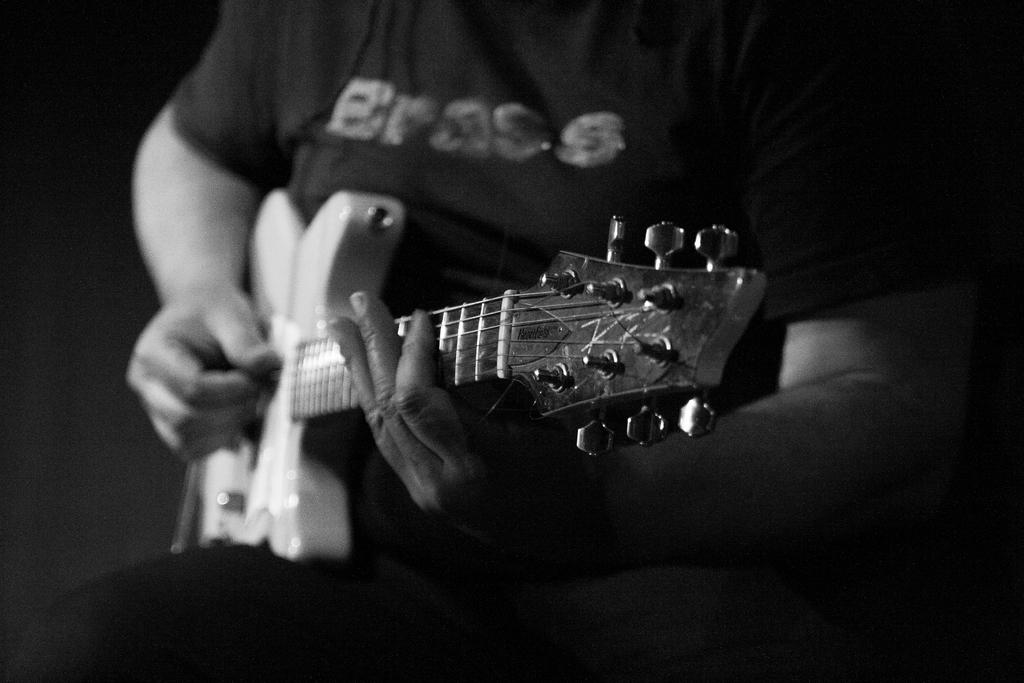What is the main subject of the image? There is a person in the image. What is the person doing in the image? The person is sitting and playing a guitar. What is the person wearing in the image? The person is wearing a black t-shirt. What type of shop can be seen in the background of the image? There is no shop visible in the image; it only features a person sitting and playing a guitar. How many cushions are present on the chair the person is sitting on? There is no chair or cushions mentioned in the image; the person is simply sitting on the ground or floor. 